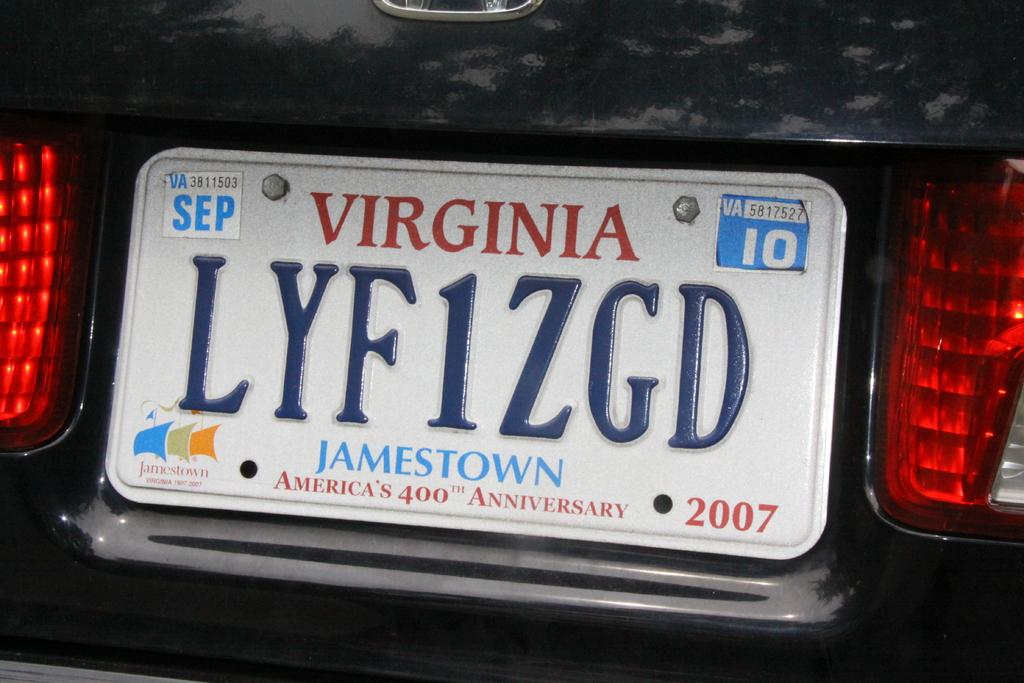What state is this plate from?
Provide a succinct answer. Virginia. 